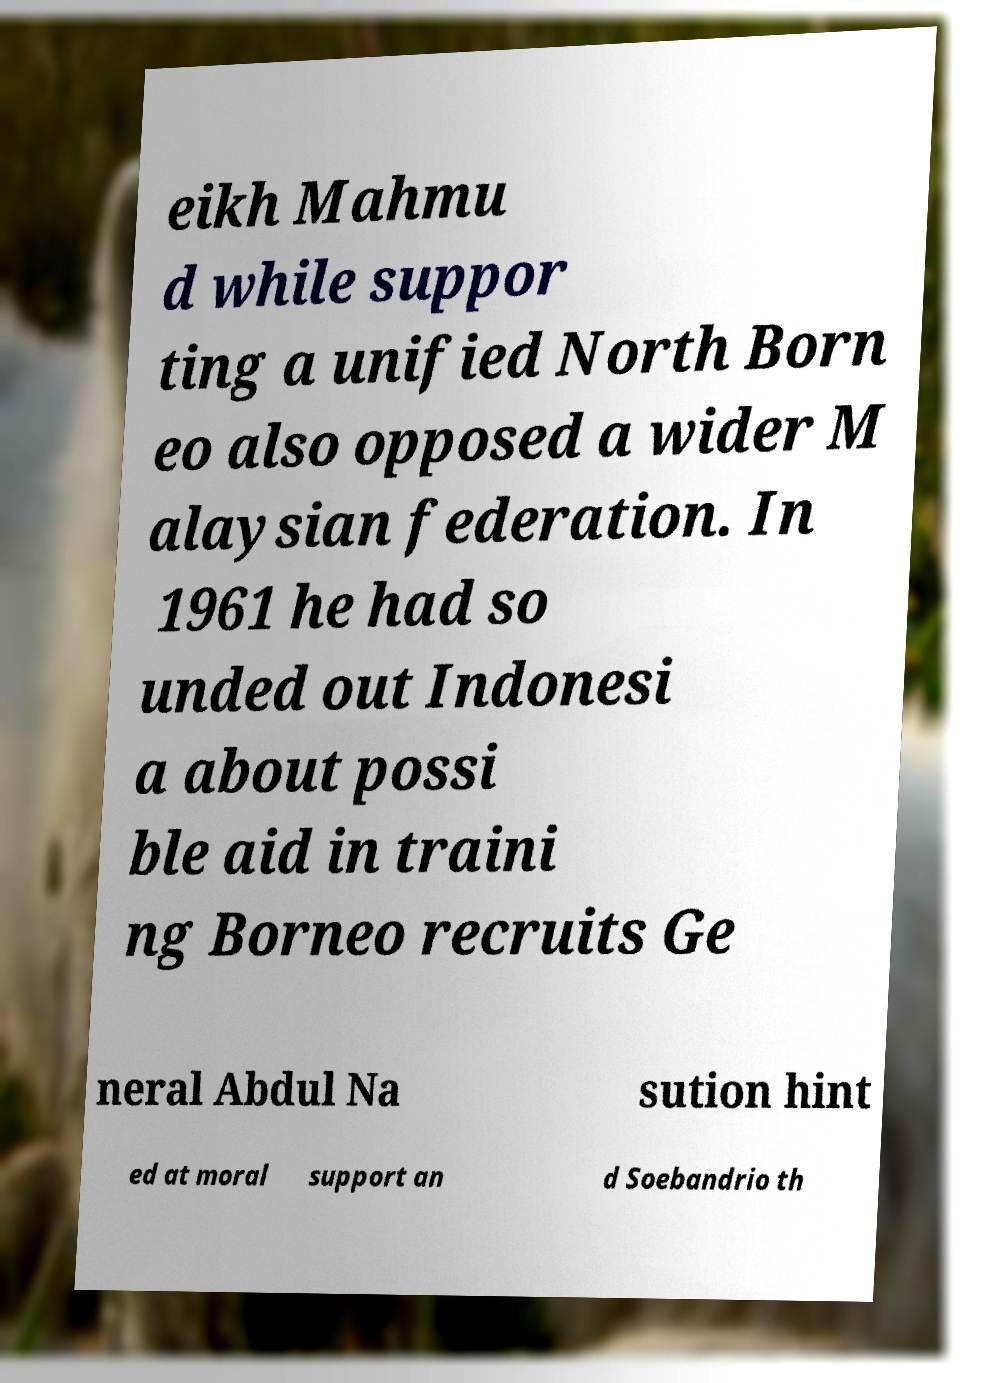Could you extract and type out the text from this image? eikh Mahmu d while suppor ting a unified North Born eo also opposed a wider M alaysian federation. In 1961 he had so unded out Indonesi a about possi ble aid in traini ng Borneo recruits Ge neral Abdul Na sution hint ed at moral support an d Soebandrio th 